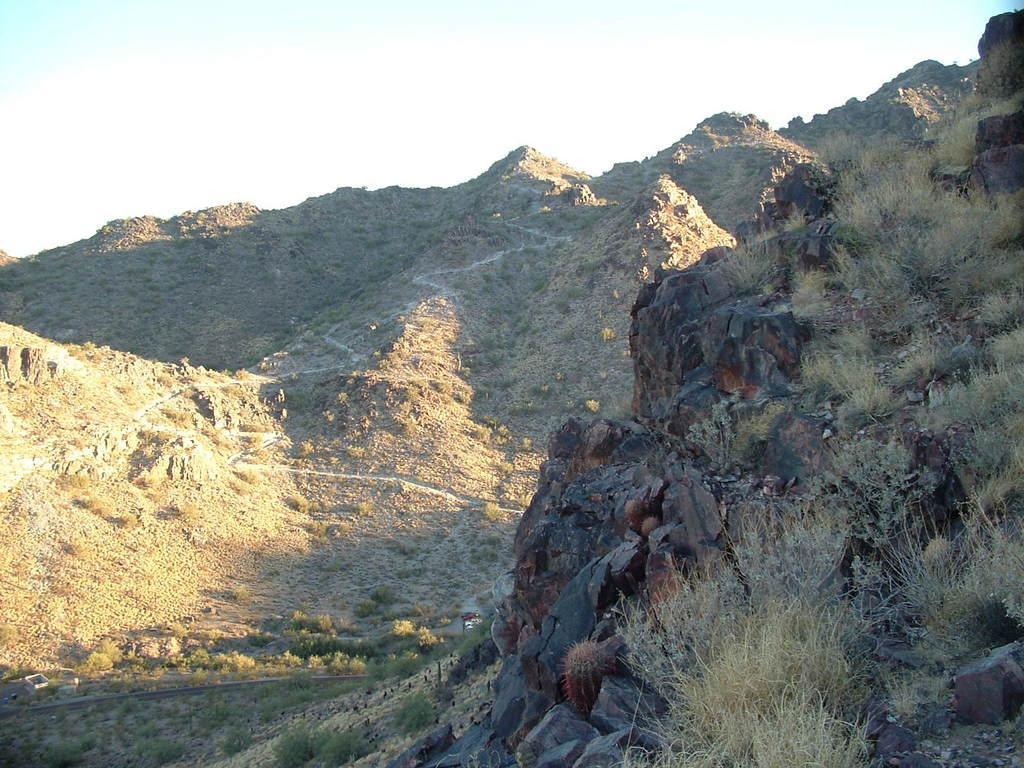In one or two sentences, can you explain what this image depicts? In this picture I can see the mountains. On the right I can see the grass. At the top I can see the small stones. At the top I can see the sky. 